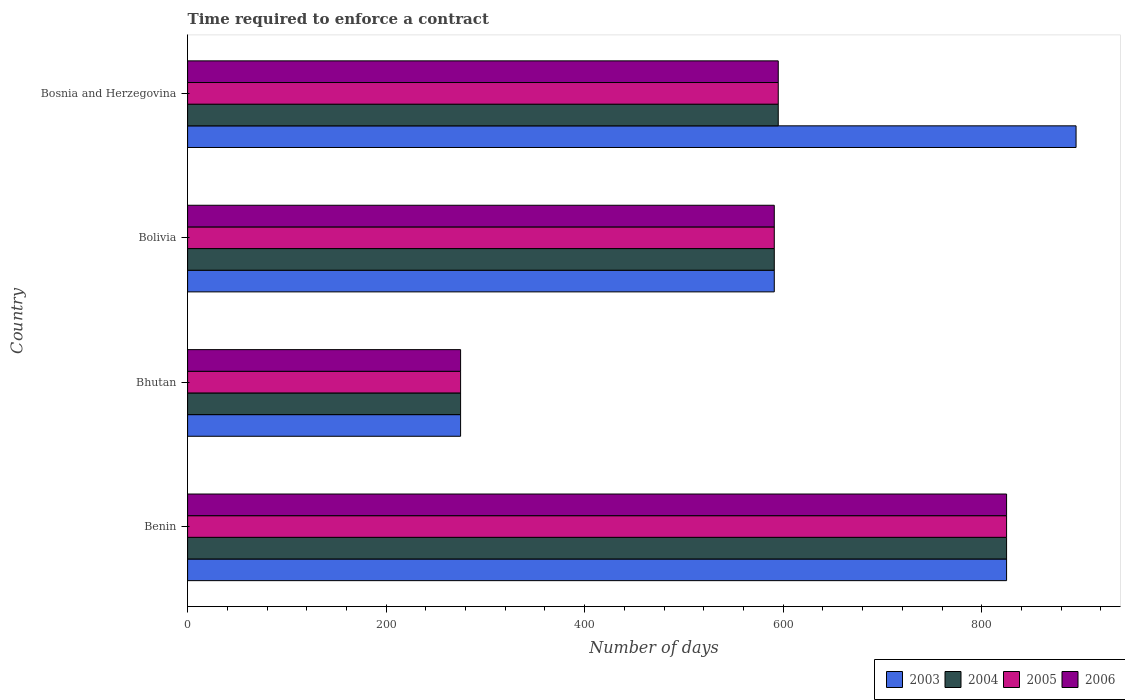How many different coloured bars are there?
Your response must be concise. 4. How many groups of bars are there?
Your answer should be very brief. 4. Are the number of bars per tick equal to the number of legend labels?
Provide a succinct answer. Yes. How many bars are there on the 2nd tick from the top?
Your response must be concise. 4. What is the label of the 2nd group of bars from the top?
Provide a succinct answer. Bolivia. In how many cases, is the number of bars for a given country not equal to the number of legend labels?
Provide a short and direct response. 0. What is the number of days required to enforce a contract in 2004 in Bosnia and Herzegovina?
Offer a very short reply. 595. Across all countries, what is the maximum number of days required to enforce a contract in 2005?
Ensure brevity in your answer.  825. Across all countries, what is the minimum number of days required to enforce a contract in 2006?
Make the answer very short. 275. In which country was the number of days required to enforce a contract in 2004 maximum?
Provide a short and direct response. Benin. In which country was the number of days required to enforce a contract in 2003 minimum?
Offer a terse response. Bhutan. What is the total number of days required to enforce a contract in 2006 in the graph?
Offer a very short reply. 2286. What is the difference between the number of days required to enforce a contract in 2003 in Bolivia and that in Bosnia and Herzegovina?
Offer a terse response. -304. What is the difference between the number of days required to enforce a contract in 2003 in Bolivia and the number of days required to enforce a contract in 2005 in Bosnia and Herzegovina?
Provide a succinct answer. -4. What is the average number of days required to enforce a contract in 2003 per country?
Keep it short and to the point. 646.5. What is the difference between the number of days required to enforce a contract in 2005 and number of days required to enforce a contract in 2003 in Bhutan?
Your answer should be very brief. 0. In how many countries, is the number of days required to enforce a contract in 2003 greater than 800 days?
Ensure brevity in your answer.  2. What is the ratio of the number of days required to enforce a contract in 2006 in Bhutan to that in Bolivia?
Your answer should be very brief. 0.47. Is the difference between the number of days required to enforce a contract in 2005 in Benin and Bolivia greater than the difference between the number of days required to enforce a contract in 2003 in Benin and Bolivia?
Your answer should be compact. No. What is the difference between the highest and the second highest number of days required to enforce a contract in 2006?
Your response must be concise. 230. What is the difference between the highest and the lowest number of days required to enforce a contract in 2004?
Offer a terse response. 550. Is the sum of the number of days required to enforce a contract in 2005 in Bolivia and Bosnia and Herzegovina greater than the maximum number of days required to enforce a contract in 2003 across all countries?
Your response must be concise. Yes. Is it the case that in every country, the sum of the number of days required to enforce a contract in 2005 and number of days required to enforce a contract in 2003 is greater than the sum of number of days required to enforce a contract in 2004 and number of days required to enforce a contract in 2006?
Offer a very short reply. No. What does the 3rd bar from the top in Bhutan represents?
Offer a terse response. 2004. What does the 4th bar from the bottom in Bhutan represents?
Provide a short and direct response. 2006. Is it the case that in every country, the sum of the number of days required to enforce a contract in 2005 and number of days required to enforce a contract in 2006 is greater than the number of days required to enforce a contract in 2003?
Provide a succinct answer. Yes. How many bars are there?
Ensure brevity in your answer.  16. Are all the bars in the graph horizontal?
Provide a succinct answer. Yes. What is the difference between two consecutive major ticks on the X-axis?
Your response must be concise. 200. Are the values on the major ticks of X-axis written in scientific E-notation?
Keep it short and to the point. No. Where does the legend appear in the graph?
Provide a short and direct response. Bottom right. How many legend labels are there?
Provide a short and direct response. 4. What is the title of the graph?
Offer a terse response. Time required to enforce a contract. Does "1969" appear as one of the legend labels in the graph?
Your answer should be very brief. No. What is the label or title of the X-axis?
Your response must be concise. Number of days. What is the Number of days in 2003 in Benin?
Your answer should be very brief. 825. What is the Number of days of 2004 in Benin?
Make the answer very short. 825. What is the Number of days in 2005 in Benin?
Ensure brevity in your answer.  825. What is the Number of days of 2006 in Benin?
Offer a very short reply. 825. What is the Number of days of 2003 in Bhutan?
Provide a succinct answer. 275. What is the Number of days of 2004 in Bhutan?
Provide a short and direct response. 275. What is the Number of days in 2005 in Bhutan?
Provide a succinct answer. 275. What is the Number of days in 2006 in Bhutan?
Offer a very short reply. 275. What is the Number of days of 2003 in Bolivia?
Your response must be concise. 591. What is the Number of days of 2004 in Bolivia?
Your response must be concise. 591. What is the Number of days in 2005 in Bolivia?
Give a very brief answer. 591. What is the Number of days in 2006 in Bolivia?
Your answer should be compact. 591. What is the Number of days in 2003 in Bosnia and Herzegovina?
Provide a succinct answer. 895. What is the Number of days in 2004 in Bosnia and Herzegovina?
Offer a very short reply. 595. What is the Number of days of 2005 in Bosnia and Herzegovina?
Provide a succinct answer. 595. What is the Number of days of 2006 in Bosnia and Herzegovina?
Make the answer very short. 595. Across all countries, what is the maximum Number of days of 2003?
Your response must be concise. 895. Across all countries, what is the maximum Number of days of 2004?
Your answer should be compact. 825. Across all countries, what is the maximum Number of days of 2005?
Ensure brevity in your answer.  825. Across all countries, what is the maximum Number of days of 2006?
Offer a very short reply. 825. Across all countries, what is the minimum Number of days of 2003?
Your answer should be compact. 275. Across all countries, what is the minimum Number of days of 2004?
Make the answer very short. 275. Across all countries, what is the minimum Number of days of 2005?
Offer a very short reply. 275. Across all countries, what is the minimum Number of days in 2006?
Provide a short and direct response. 275. What is the total Number of days in 2003 in the graph?
Your answer should be very brief. 2586. What is the total Number of days in 2004 in the graph?
Offer a very short reply. 2286. What is the total Number of days in 2005 in the graph?
Ensure brevity in your answer.  2286. What is the total Number of days in 2006 in the graph?
Make the answer very short. 2286. What is the difference between the Number of days in 2003 in Benin and that in Bhutan?
Your answer should be very brief. 550. What is the difference between the Number of days of 2004 in Benin and that in Bhutan?
Keep it short and to the point. 550. What is the difference between the Number of days in 2005 in Benin and that in Bhutan?
Your response must be concise. 550. What is the difference between the Number of days in 2006 in Benin and that in Bhutan?
Offer a very short reply. 550. What is the difference between the Number of days of 2003 in Benin and that in Bolivia?
Your response must be concise. 234. What is the difference between the Number of days in 2004 in Benin and that in Bolivia?
Your answer should be compact. 234. What is the difference between the Number of days of 2005 in Benin and that in Bolivia?
Make the answer very short. 234. What is the difference between the Number of days of 2006 in Benin and that in Bolivia?
Make the answer very short. 234. What is the difference between the Number of days in 2003 in Benin and that in Bosnia and Herzegovina?
Offer a terse response. -70. What is the difference between the Number of days of 2004 in Benin and that in Bosnia and Herzegovina?
Your response must be concise. 230. What is the difference between the Number of days of 2005 in Benin and that in Bosnia and Herzegovina?
Give a very brief answer. 230. What is the difference between the Number of days in 2006 in Benin and that in Bosnia and Herzegovina?
Keep it short and to the point. 230. What is the difference between the Number of days in 2003 in Bhutan and that in Bolivia?
Your answer should be compact. -316. What is the difference between the Number of days of 2004 in Bhutan and that in Bolivia?
Your answer should be very brief. -316. What is the difference between the Number of days in 2005 in Bhutan and that in Bolivia?
Keep it short and to the point. -316. What is the difference between the Number of days of 2006 in Bhutan and that in Bolivia?
Your answer should be compact. -316. What is the difference between the Number of days in 2003 in Bhutan and that in Bosnia and Herzegovina?
Give a very brief answer. -620. What is the difference between the Number of days in 2004 in Bhutan and that in Bosnia and Herzegovina?
Offer a very short reply. -320. What is the difference between the Number of days of 2005 in Bhutan and that in Bosnia and Herzegovina?
Your answer should be compact. -320. What is the difference between the Number of days in 2006 in Bhutan and that in Bosnia and Herzegovina?
Make the answer very short. -320. What is the difference between the Number of days of 2003 in Bolivia and that in Bosnia and Herzegovina?
Offer a terse response. -304. What is the difference between the Number of days of 2006 in Bolivia and that in Bosnia and Herzegovina?
Give a very brief answer. -4. What is the difference between the Number of days in 2003 in Benin and the Number of days in 2004 in Bhutan?
Provide a short and direct response. 550. What is the difference between the Number of days in 2003 in Benin and the Number of days in 2005 in Bhutan?
Provide a succinct answer. 550. What is the difference between the Number of days in 2003 in Benin and the Number of days in 2006 in Bhutan?
Your answer should be very brief. 550. What is the difference between the Number of days of 2004 in Benin and the Number of days of 2005 in Bhutan?
Keep it short and to the point. 550. What is the difference between the Number of days in 2004 in Benin and the Number of days in 2006 in Bhutan?
Offer a very short reply. 550. What is the difference between the Number of days of 2005 in Benin and the Number of days of 2006 in Bhutan?
Your answer should be very brief. 550. What is the difference between the Number of days of 2003 in Benin and the Number of days of 2004 in Bolivia?
Provide a succinct answer. 234. What is the difference between the Number of days of 2003 in Benin and the Number of days of 2005 in Bolivia?
Your response must be concise. 234. What is the difference between the Number of days in 2003 in Benin and the Number of days in 2006 in Bolivia?
Provide a succinct answer. 234. What is the difference between the Number of days in 2004 in Benin and the Number of days in 2005 in Bolivia?
Your response must be concise. 234. What is the difference between the Number of days in 2004 in Benin and the Number of days in 2006 in Bolivia?
Your answer should be very brief. 234. What is the difference between the Number of days in 2005 in Benin and the Number of days in 2006 in Bolivia?
Keep it short and to the point. 234. What is the difference between the Number of days in 2003 in Benin and the Number of days in 2004 in Bosnia and Herzegovina?
Provide a succinct answer. 230. What is the difference between the Number of days of 2003 in Benin and the Number of days of 2005 in Bosnia and Herzegovina?
Your answer should be very brief. 230. What is the difference between the Number of days of 2003 in Benin and the Number of days of 2006 in Bosnia and Herzegovina?
Make the answer very short. 230. What is the difference between the Number of days in 2004 in Benin and the Number of days in 2005 in Bosnia and Herzegovina?
Ensure brevity in your answer.  230. What is the difference between the Number of days of 2004 in Benin and the Number of days of 2006 in Bosnia and Herzegovina?
Provide a short and direct response. 230. What is the difference between the Number of days in 2005 in Benin and the Number of days in 2006 in Bosnia and Herzegovina?
Offer a very short reply. 230. What is the difference between the Number of days in 2003 in Bhutan and the Number of days in 2004 in Bolivia?
Offer a very short reply. -316. What is the difference between the Number of days in 2003 in Bhutan and the Number of days in 2005 in Bolivia?
Your response must be concise. -316. What is the difference between the Number of days of 2003 in Bhutan and the Number of days of 2006 in Bolivia?
Offer a terse response. -316. What is the difference between the Number of days in 2004 in Bhutan and the Number of days in 2005 in Bolivia?
Make the answer very short. -316. What is the difference between the Number of days of 2004 in Bhutan and the Number of days of 2006 in Bolivia?
Keep it short and to the point. -316. What is the difference between the Number of days of 2005 in Bhutan and the Number of days of 2006 in Bolivia?
Your answer should be very brief. -316. What is the difference between the Number of days in 2003 in Bhutan and the Number of days in 2004 in Bosnia and Herzegovina?
Make the answer very short. -320. What is the difference between the Number of days of 2003 in Bhutan and the Number of days of 2005 in Bosnia and Herzegovina?
Provide a short and direct response. -320. What is the difference between the Number of days of 2003 in Bhutan and the Number of days of 2006 in Bosnia and Herzegovina?
Your answer should be very brief. -320. What is the difference between the Number of days in 2004 in Bhutan and the Number of days in 2005 in Bosnia and Herzegovina?
Keep it short and to the point. -320. What is the difference between the Number of days in 2004 in Bhutan and the Number of days in 2006 in Bosnia and Herzegovina?
Provide a short and direct response. -320. What is the difference between the Number of days in 2005 in Bhutan and the Number of days in 2006 in Bosnia and Herzegovina?
Your response must be concise. -320. What is the difference between the Number of days of 2003 in Bolivia and the Number of days of 2004 in Bosnia and Herzegovina?
Give a very brief answer. -4. What is the difference between the Number of days in 2003 in Bolivia and the Number of days in 2005 in Bosnia and Herzegovina?
Your answer should be very brief. -4. What is the average Number of days in 2003 per country?
Ensure brevity in your answer.  646.5. What is the average Number of days of 2004 per country?
Your answer should be very brief. 571.5. What is the average Number of days of 2005 per country?
Your answer should be compact. 571.5. What is the average Number of days in 2006 per country?
Keep it short and to the point. 571.5. What is the difference between the Number of days in 2003 and Number of days in 2004 in Benin?
Provide a succinct answer. 0. What is the difference between the Number of days in 2003 and Number of days in 2005 in Benin?
Provide a short and direct response. 0. What is the difference between the Number of days of 2003 and Number of days of 2006 in Benin?
Ensure brevity in your answer.  0. What is the difference between the Number of days of 2004 and Number of days of 2006 in Benin?
Offer a very short reply. 0. What is the difference between the Number of days in 2004 and Number of days in 2005 in Bhutan?
Ensure brevity in your answer.  0. What is the difference between the Number of days of 2004 and Number of days of 2006 in Bhutan?
Your response must be concise. 0. What is the difference between the Number of days of 2005 and Number of days of 2006 in Bolivia?
Your response must be concise. 0. What is the difference between the Number of days of 2003 and Number of days of 2004 in Bosnia and Herzegovina?
Offer a terse response. 300. What is the difference between the Number of days of 2003 and Number of days of 2005 in Bosnia and Herzegovina?
Provide a short and direct response. 300. What is the difference between the Number of days of 2003 and Number of days of 2006 in Bosnia and Herzegovina?
Give a very brief answer. 300. What is the difference between the Number of days in 2005 and Number of days in 2006 in Bosnia and Herzegovina?
Provide a succinct answer. 0. What is the ratio of the Number of days in 2005 in Benin to that in Bhutan?
Your answer should be very brief. 3. What is the ratio of the Number of days of 2006 in Benin to that in Bhutan?
Keep it short and to the point. 3. What is the ratio of the Number of days of 2003 in Benin to that in Bolivia?
Keep it short and to the point. 1.4. What is the ratio of the Number of days of 2004 in Benin to that in Bolivia?
Your response must be concise. 1.4. What is the ratio of the Number of days of 2005 in Benin to that in Bolivia?
Ensure brevity in your answer.  1.4. What is the ratio of the Number of days in 2006 in Benin to that in Bolivia?
Offer a very short reply. 1.4. What is the ratio of the Number of days in 2003 in Benin to that in Bosnia and Herzegovina?
Provide a succinct answer. 0.92. What is the ratio of the Number of days of 2004 in Benin to that in Bosnia and Herzegovina?
Make the answer very short. 1.39. What is the ratio of the Number of days in 2005 in Benin to that in Bosnia and Herzegovina?
Keep it short and to the point. 1.39. What is the ratio of the Number of days of 2006 in Benin to that in Bosnia and Herzegovina?
Ensure brevity in your answer.  1.39. What is the ratio of the Number of days of 2003 in Bhutan to that in Bolivia?
Ensure brevity in your answer.  0.47. What is the ratio of the Number of days in 2004 in Bhutan to that in Bolivia?
Ensure brevity in your answer.  0.47. What is the ratio of the Number of days of 2005 in Bhutan to that in Bolivia?
Your response must be concise. 0.47. What is the ratio of the Number of days of 2006 in Bhutan to that in Bolivia?
Your answer should be very brief. 0.47. What is the ratio of the Number of days of 2003 in Bhutan to that in Bosnia and Herzegovina?
Your answer should be compact. 0.31. What is the ratio of the Number of days in 2004 in Bhutan to that in Bosnia and Herzegovina?
Ensure brevity in your answer.  0.46. What is the ratio of the Number of days in 2005 in Bhutan to that in Bosnia and Herzegovina?
Offer a very short reply. 0.46. What is the ratio of the Number of days in 2006 in Bhutan to that in Bosnia and Herzegovina?
Give a very brief answer. 0.46. What is the ratio of the Number of days of 2003 in Bolivia to that in Bosnia and Herzegovina?
Your answer should be very brief. 0.66. What is the ratio of the Number of days in 2005 in Bolivia to that in Bosnia and Herzegovina?
Ensure brevity in your answer.  0.99. What is the ratio of the Number of days of 2006 in Bolivia to that in Bosnia and Herzegovina?
Keep it short and to the point. 0.99. What is the difference between the highest and the second highest Number of days of 2004?
Provide a succinct answer. 230. What is the difference between the highest and the second highest Number of days in 2005?
Keep it short and to the point. 230. What is the difference between the highest and the second highest Number of days in 2006?
Offer a terse response. 230. What is the difference between the highest and the lowest Number of days of 2003?
Your answer should be compact. 620. What is the difference between the highest and the lowest Number of days in 2004?
Offer a very short reply. 550. What is the difference between the highest and the lowest Number of days of 2005?
Your answer should be compact. 550. What is the difference between the highest and the lowest Number of days of 2006?
Your answer should be very brief. 550. 